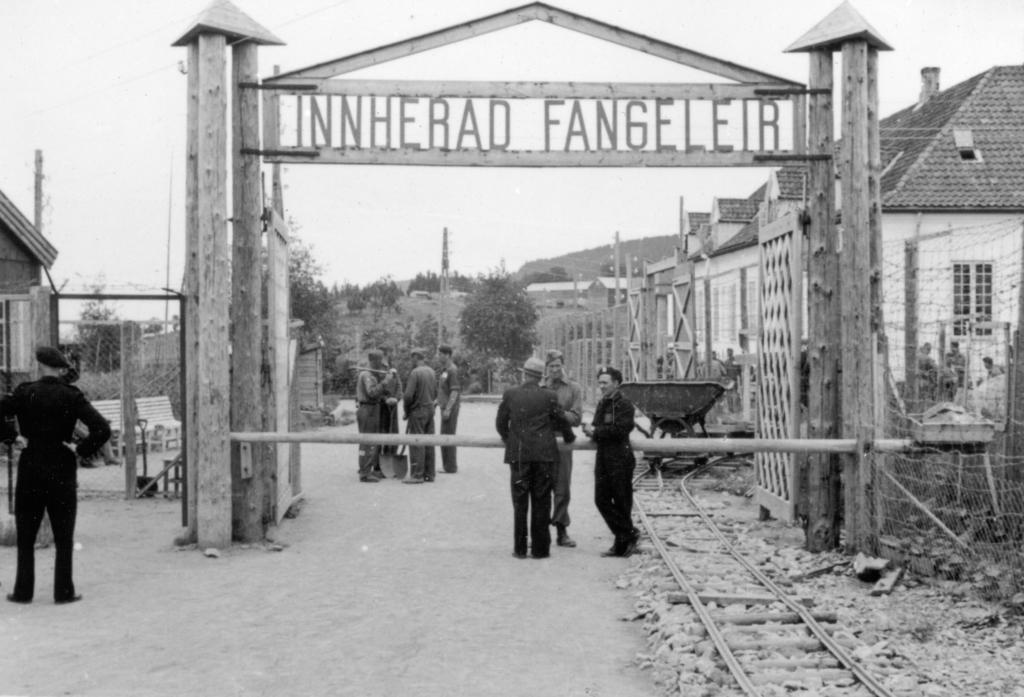In one or two sentences, can you explain what this image depicts? In this black and white picture there are few people standing. In the foreground there is a gate to an arch. There is text on the arch. There is a railway track on the ground. To the right there is a net. In the background there are houses, trees and poles. At the top there is the sky. 